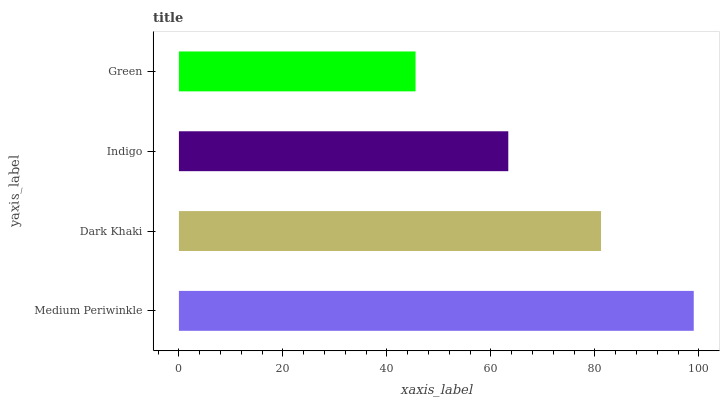Is Green the minimum?
Answer yes or no. Yes. Is Medium Periwinkle the maximum?
Answer yes or no. Yes. Is Dark Khaki the minimum?
Answer yes or no. No. Is Dark Khaki the maximum?
Answer yes or no. No. Is Medium Periwinkle greater than Dark Khaki?
Answer yes or no. Yes. Is Dark Khaki less than Medium Periwinkle?
Answer yes or no. Yes. Is Dark Khaki greater than Medium Periwinkle?
Answer yes or no. No. Is Medium Periwinkle less than Dark Khaki?
Answer yes or no. No. Is Dark Khaki the high median?
Answer yes or no. Yes. Is Indigo the low median?
Answer yes or no. Yes. Is Indigo the high median?
Answer yes or no. No. Is Medium Periwinkle the low median?
Answer yes or no. No. 